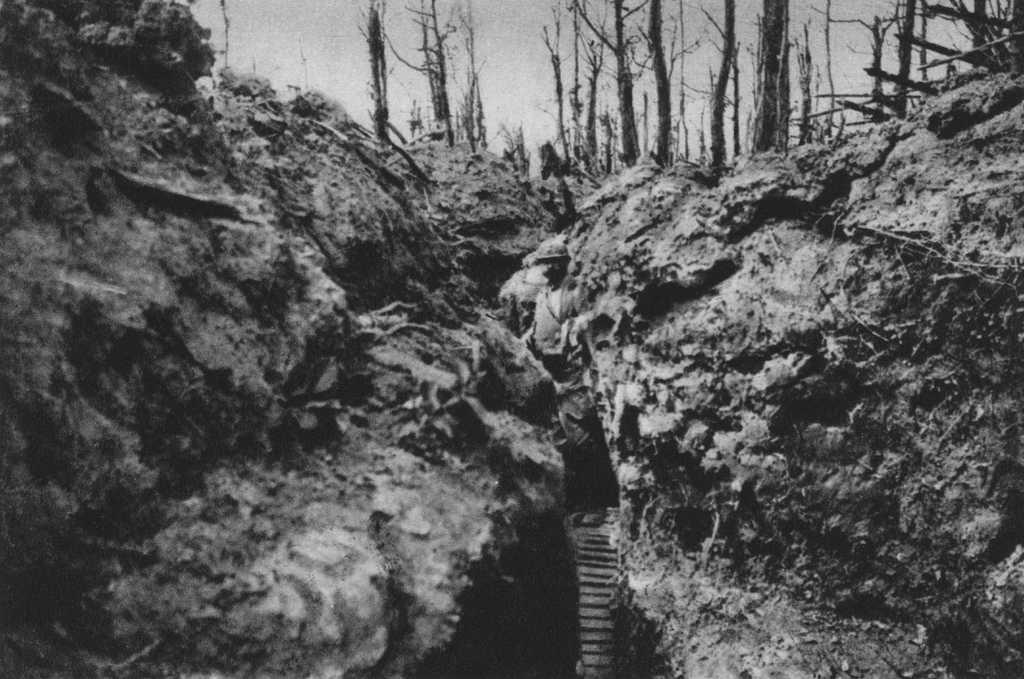What is the main subject of the image? There is a man standing in the image. Where is the image set? The image is set in a forest. What is the color scheme of the image? The image is black and white. What can be seen at the top of the image? Trees are visible at the top of the image. How many planes can be seen flying over the forest in the image? There are no planes visible in the image; it is set in a forest with a man standing. What type of ice is being sold in the image? There is no ice or any indication of a sale in the image; it is a black and white photograph of a man standing in a forest. 